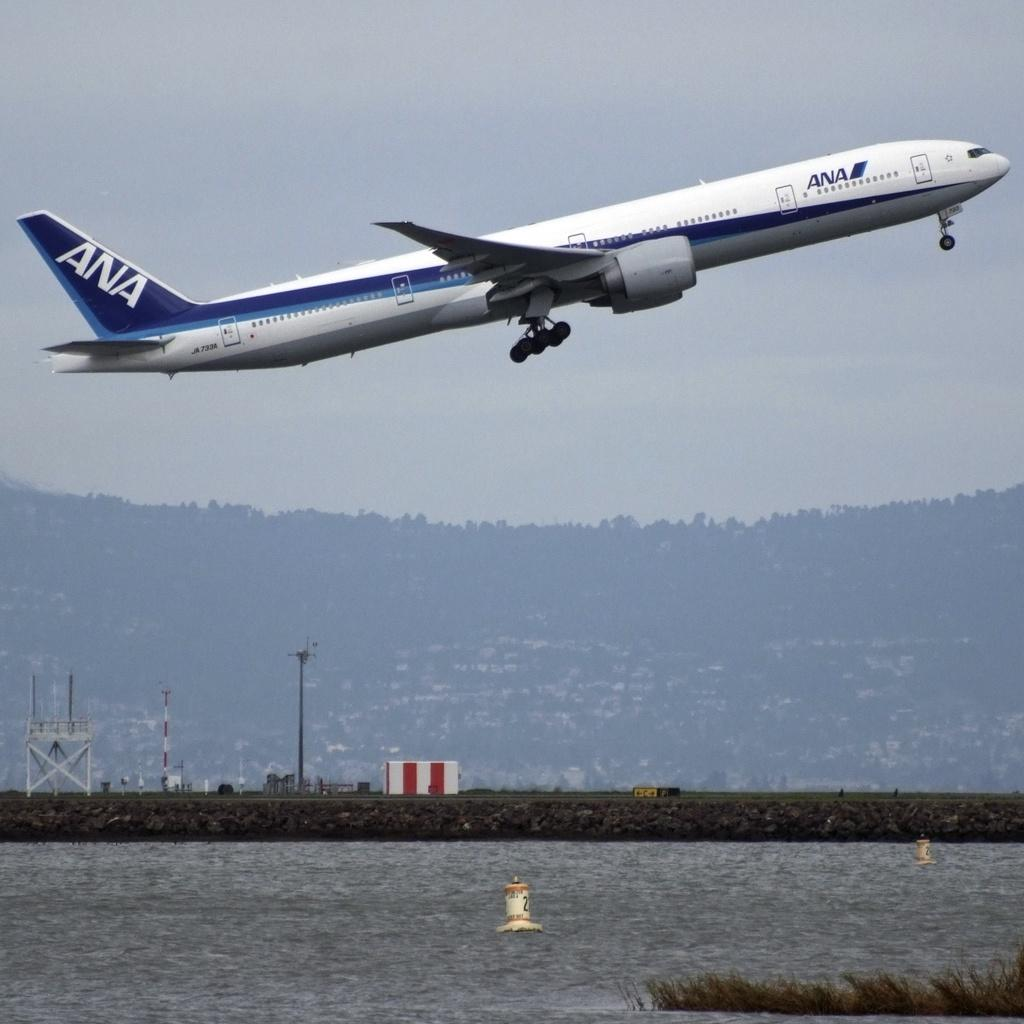<image>
Provide a brief description of the given image. a plane with ANA on the side of it 